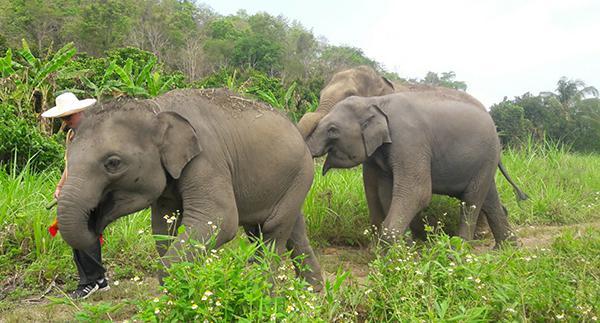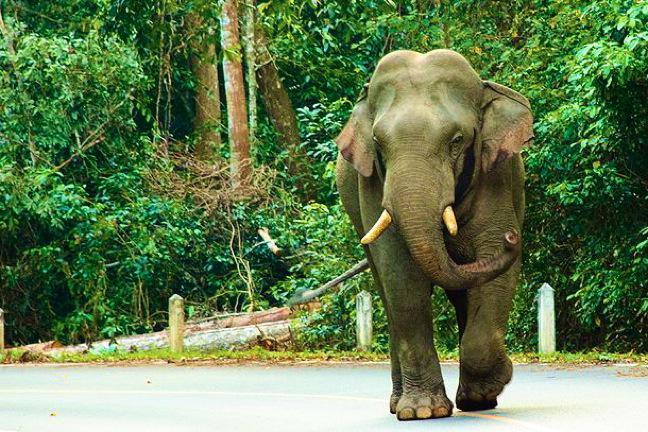The first image is the image on the left, the second image is the image on the right. Given the left and right images, does the statement "There are no more than 4 elephants in the image pair" hold true? Answer yes or no. Yes. The first image is the image on the left, the second image is the image on the right. Considering the images on both sides, is "There are at least six elephants." valid? Answer yes or no. No. 